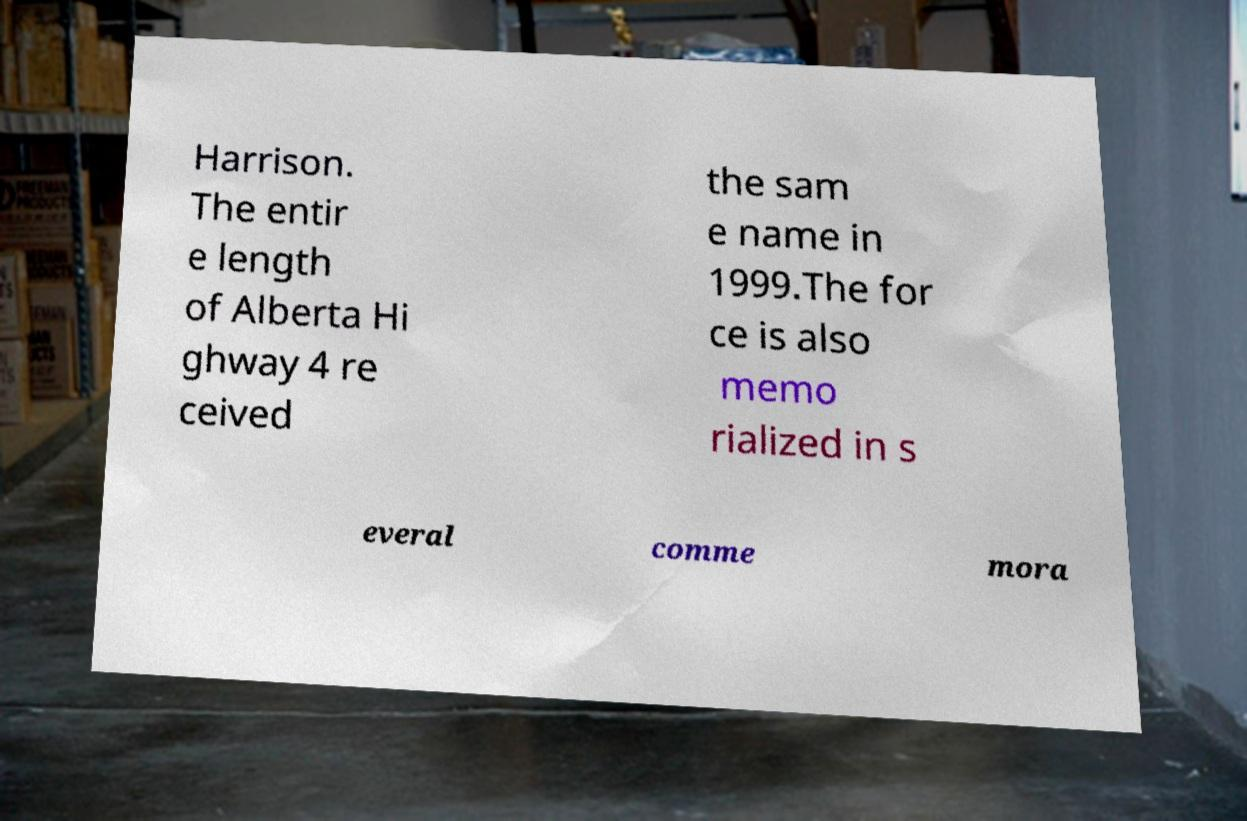For documentation purposes, I need the text within this image transcribed. Could you provide that? Harrison. The entir e length of Alberta Hi ghway 4 re ceived the sam e name in 1999.The for ce is also memo rialized in s everal comme mora 